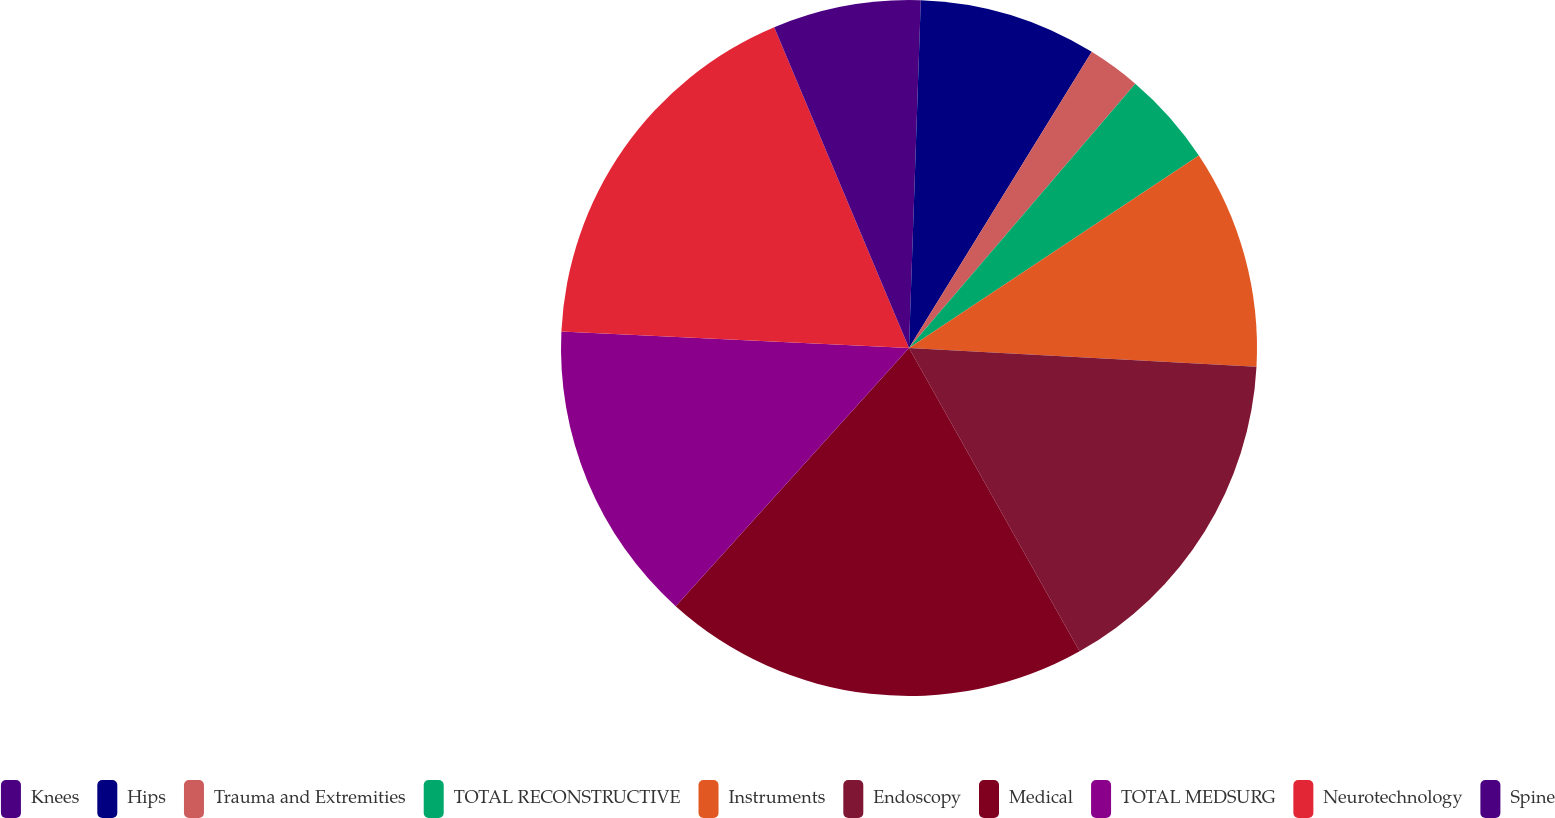Convert chart. <chart><loc_0><loc_0><loc_500><loc_500><pie_chart><fcel>Knees<fcel>Hips<fcel>Trauma and Extremities<fcel>TOTAL RECONSTRUCTIVE<fcel>Instruments<fcel>Endoscopy<fcel>Medical<fcel>TOTAL MEDSURG<fcel>Neurotechnology<fcel>Spine<nl><fcel>0.54%<fcel>8.26%<fcel>2.47%<fcel>4.4%<fcel>10.19%<fcel>15.99%<fcel>19.85%<fcel>14.06%<fcel>17.92%<fcel>6.33%<nl></chart> 